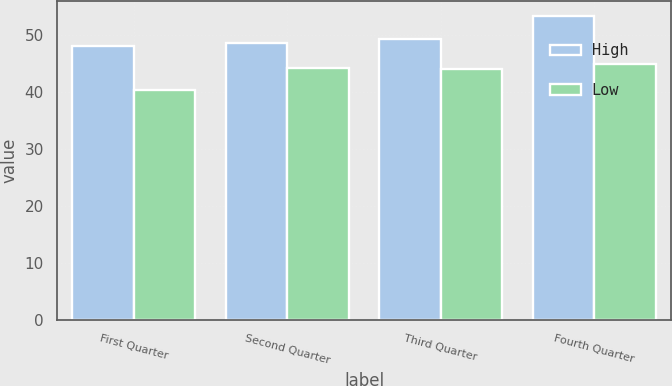<chart> <loc_0><loc_0><loc_500><loc_500><stacked_bar_chart><ecel><fcel>First Quarter<fcel>Second Quarter<fcel>Third Quarter<fcel>Fourth Quarter<nl><fcel>High<fcel>48.01<fcel>48.59<fcel>49.28<fcel>53.35<nl><fcel>Low<fcel>40.45<fcel>44.23<fcel>44.06<fcel>44.93<nl></chart> 